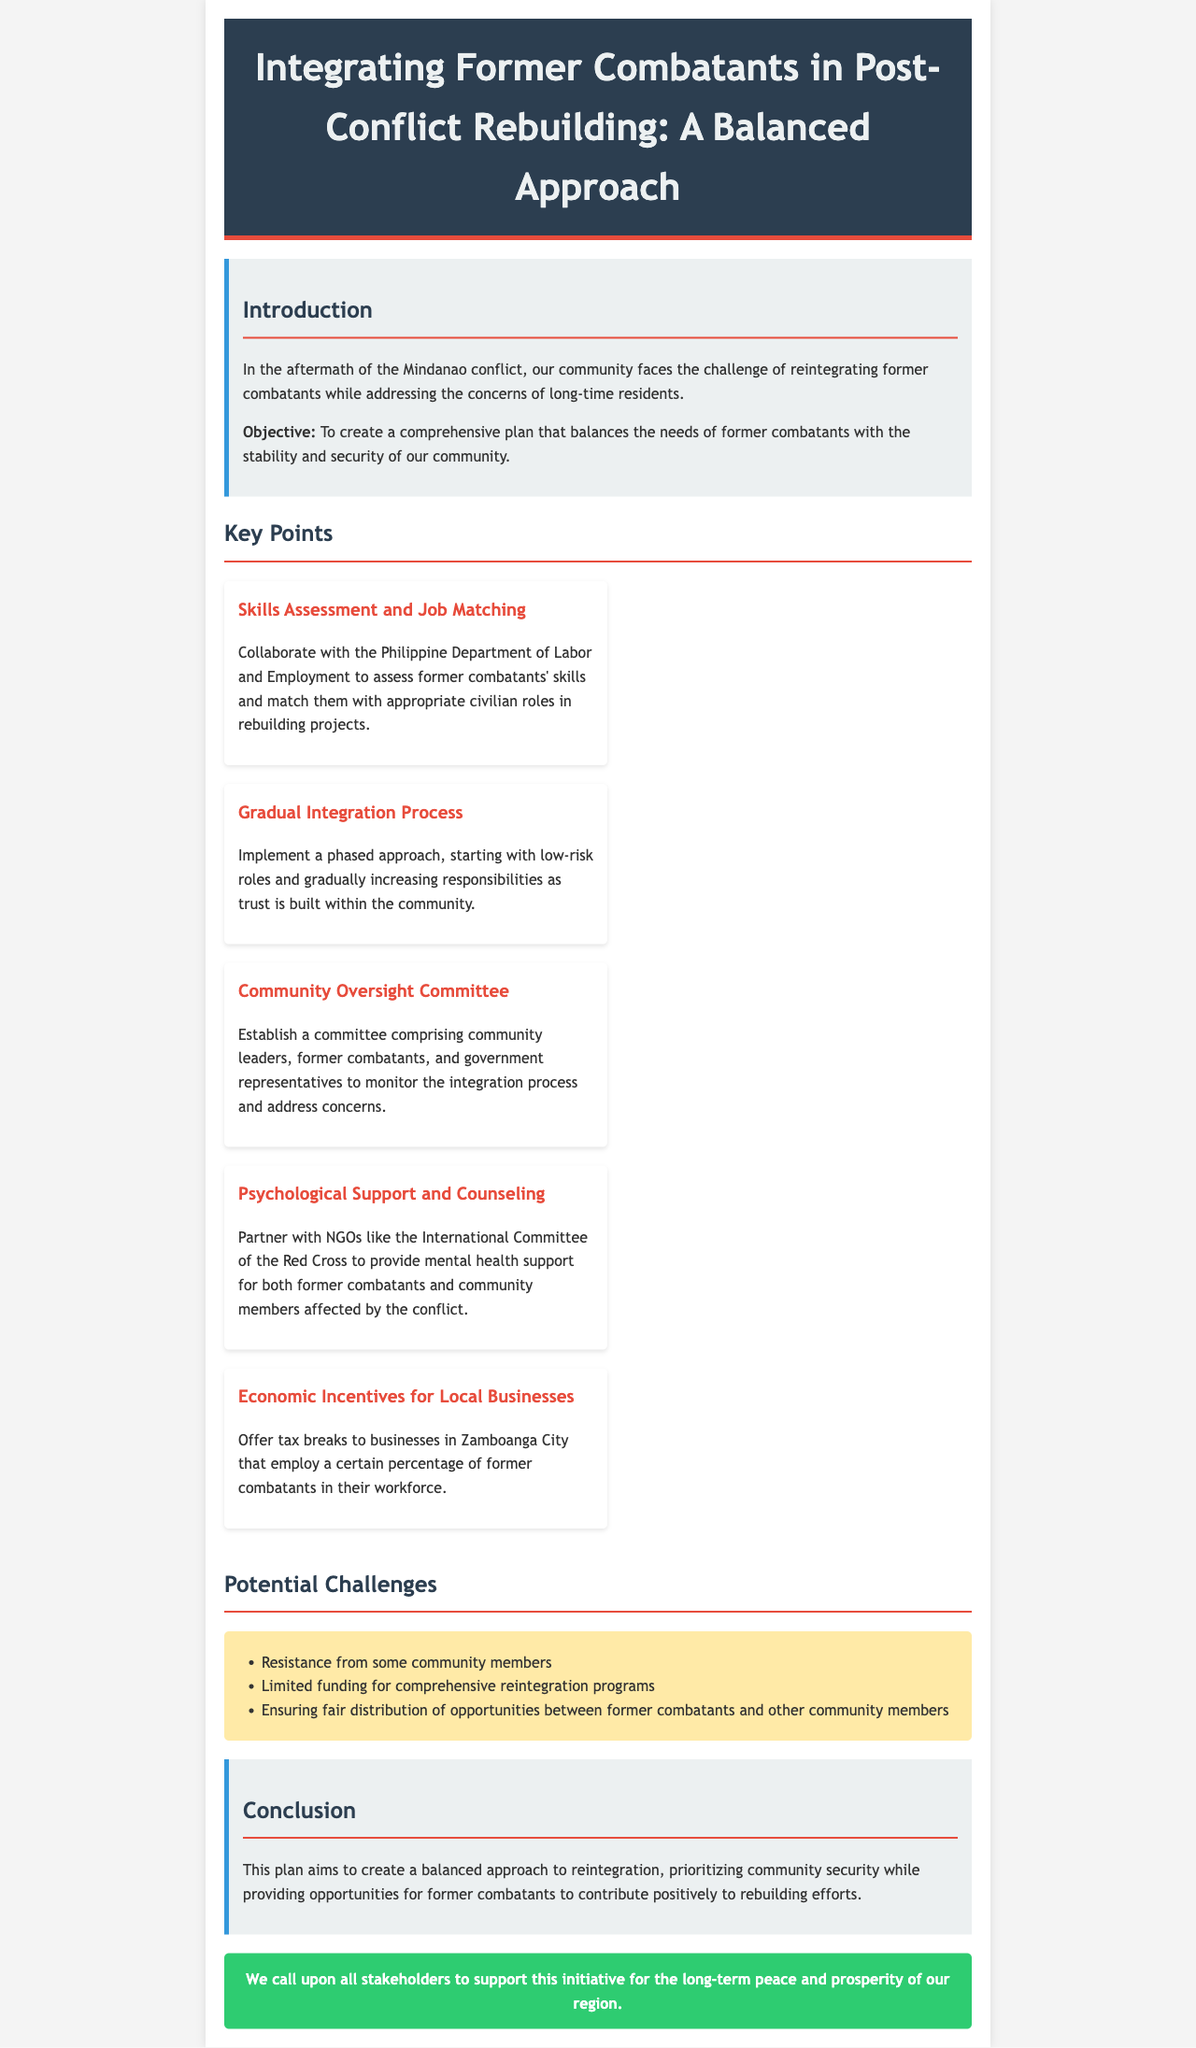what is the main objective of the comprehensive plan? The objective is to create a comprehensive plan that balances the needs of former combatants with the stability and security of the community.
Answer: to create a comprehensive plan that balances the needs of former combatants with the stability and security of our community what is one of the key points for integrating former combatants? One of the key points is to collaborate with the Philippine Department of Labor and Employment to assess former combatants' skills.
Answer: Skills Assessment and Job Matching how many key points are mentioned in the document? There are five key points listed in the document regarding the integration of former combatants.
Answer: five who is responsible for establishing the Community Oversight Committee? The committee comprises community leaders, former combatants, and government representatives.
Answer: community leaders, former combatants, and government representatives what type of support is mentioned for former combatants? Psychological support and counseling are highlighted as crucial for former combatants.
Answer: Psychological Support and Counseling what is a potential challenge mentioned in the document? One potential challenge is resistance from some community members regarding the reintegration process.
Answer: Resistance from some community members what action is suggested to encourage local businesses? The plan suggests offering tax breaks to businesses that employ former combatants.
Answer: offer tax breaks to businesses what is the target community referred to in the economic incentives? The target community mentioned for the economic incentives is Zamboanga City.
Answer: Zamboanga City 